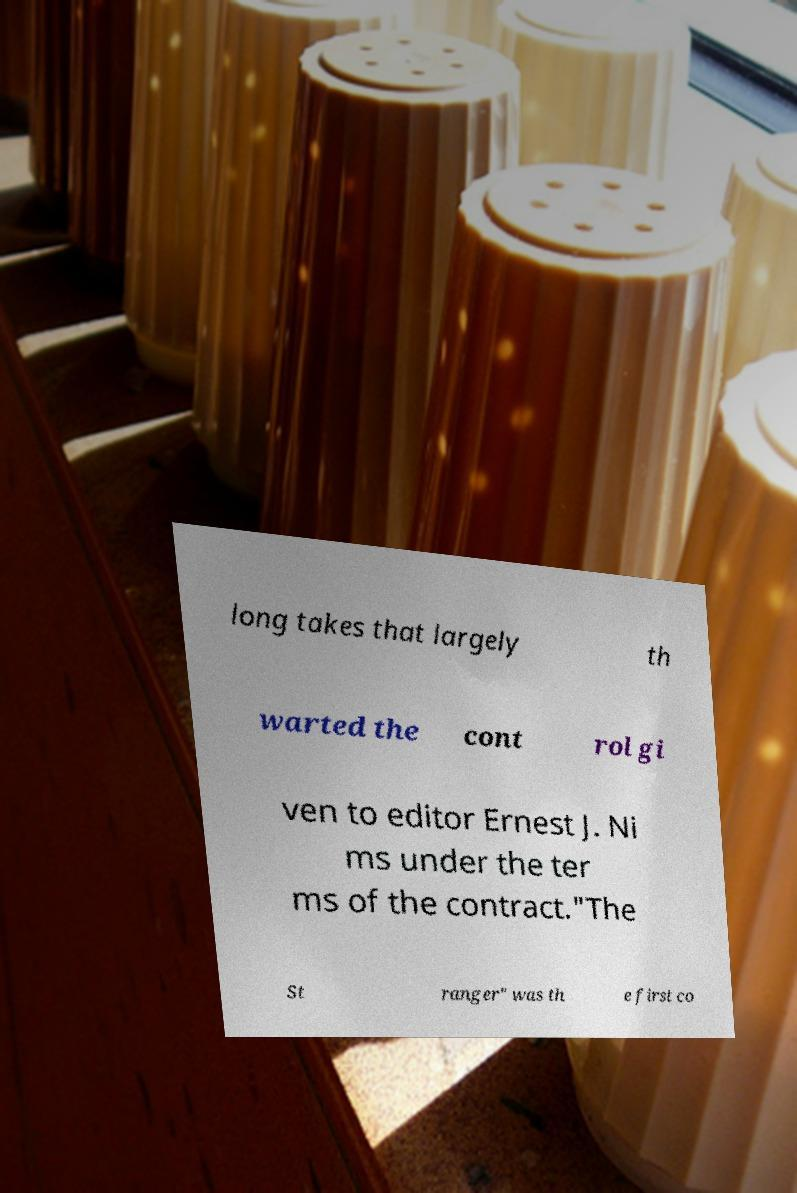For documentation purposes, I need the text within this image transcribed. Could you provide that? long takes that largely th warted the cont rol gi ven to editor Ernest J. Ni ms under the ter ms of the contract."The St ranger" was th e first co 